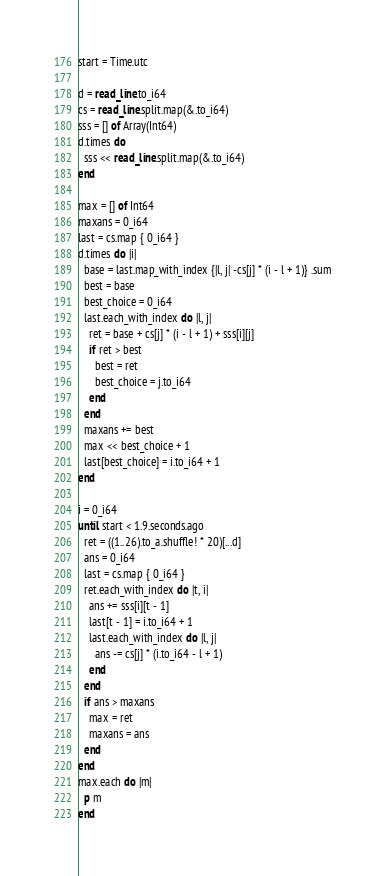Convert code to text. <code><loc_0><loc_0><loc_500><loc_500><_Crystal_>start = Time.utc

d = read_line.to_i64
cs = read_line.split.map(&.to_i64)
sss = [] of Array(Int64)
d.times do
  sss << read_line.split.map(&.to_i64)
end

max = [] of Int64
maxans = 0_i64
last = cs.map { 0_i64 }
d.times do |i|
  base = last.map_with_index {|l, j| -cs[j] * (i - l + 1)} .sum
  best = base
  best_choice = 0_i64
  last.each_with_index do |l, j|
    ret = base + cs[j] * (i - l + 1) + sss[i][j]
    if ret > best
      best = ret
      best_choice = j.to_i64
    end
  end
  maxans += best
  max << best_choice + 1
  last[best_choice] = i.to_i64 + 1
end

i = 0_i64
until start < 1.9.seconds.ago
  ret = ((1..26).to_a.shuffle! * 20)[...d]
  ans = 0_i64
  last = cs.map { 0_i64 }
  ret.each_with_index do |t, i|
    ans += sss[i][t - 1]
    last[t - 1] = i.to_i64 + 1
    last.each_with_index do |l, j|
      ans -= cs[j] * (i.to_i64 - l + 1)
    end
  end
  if ans > maxans
    max = ret
    maxans = ans
  end
end
max.each do |m|
  p m
end</code> 